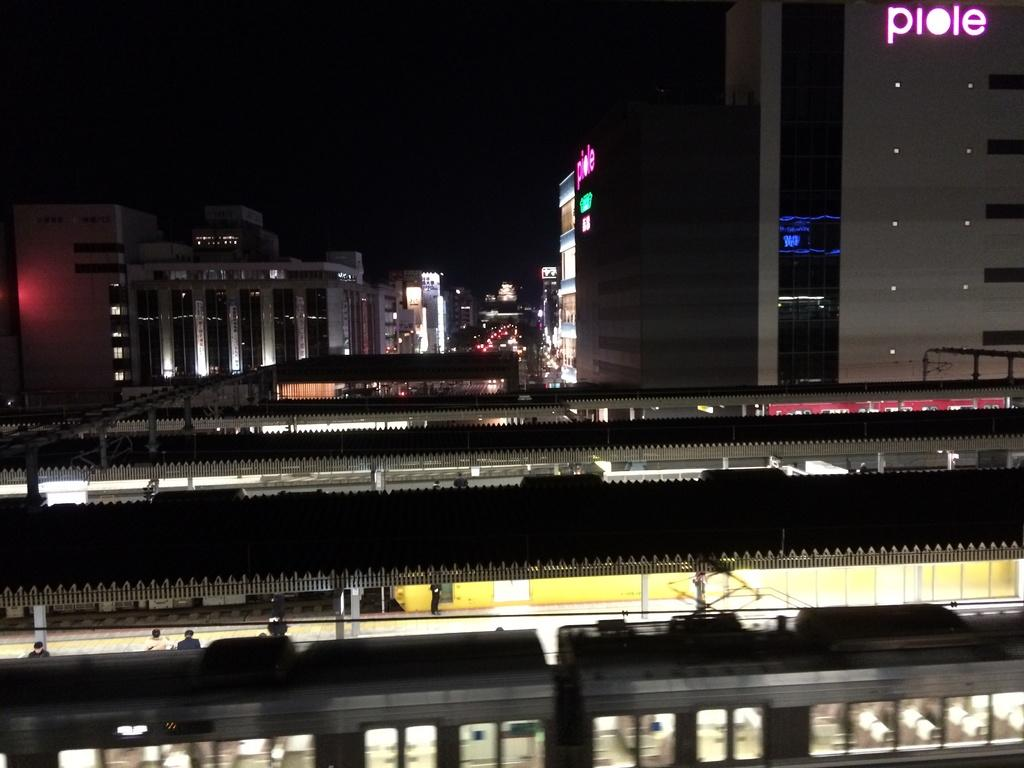<image>
Summarize the visual content of the image. Behind a train in a large building with "piole" written on the side. 